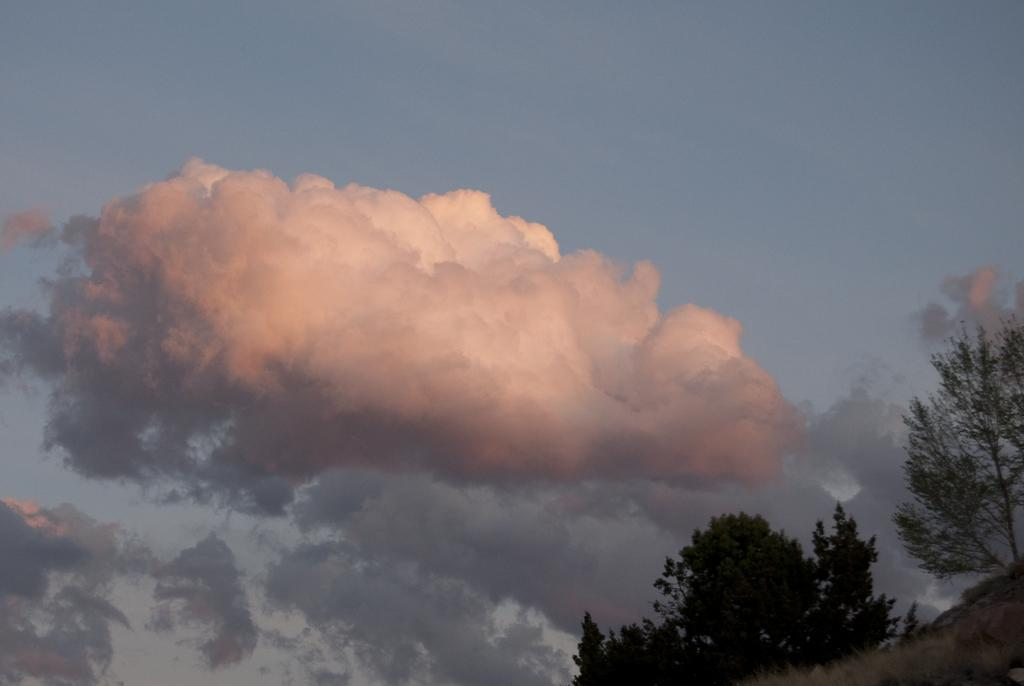What type of vegetation is on the right side of the image? There are trees on the right side of the image. What is visible in the background of the image? The sky is visible in the background of the image. What can be seen in the sky in the image? Clouds are present in the background of the image. What type of force is being exerted on the corn in the image? There is no corn present in the image, so it is not possible to determine if any force is being exerted on it. Can you tell me how many chess pieces are visible in the image? There are no chess pieces visible in the image. 